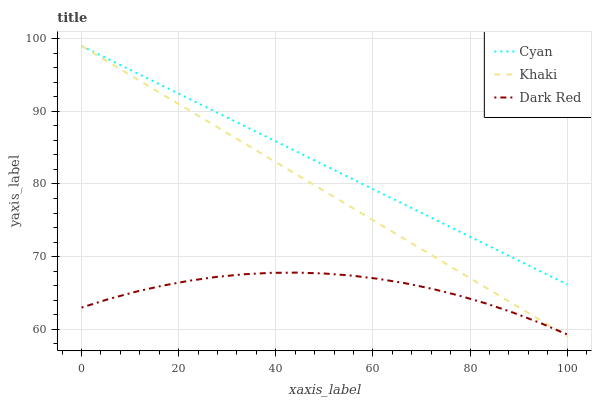Does Dark Red have the minimum area under the curve?
Answer yes or no. Yes. Does Cyan have the maximum area under the curve?
Answer yes or no. Yes. Does Khaki have the minimum area under the curve?
Answer yes or no. No. Does Khaki have the maximum area under the curve?
Answer yes or no. No. Is Khaki the smoothest?
Answer yes or no. Yes. Is Dark Red the roughest?
Answer yes or no. Yes. Is Dark Red the smoothest?
Answer yes or no. No. Is Khaki the roughest?
Answer yes or no. No. Does Khaki have the lowest value?
Answer yes or no. Yes. Does Dark Red have the lowest value?
Answer yes or no. No. Does Khaki have the highest value?
Answer yes or no. Yes. Does Dark Red have the highest value?
Answer yes or no. No. Is Dark Red less than Cyan?
Answer yes or no. Yes. Is Cyan greater than Dark Red?
Answer yes or no. Yes. Does Khaki intersect Dark Red?
Answer yes or no. Yes. Is Khaki less than Dark Red?
Answer yes or no. No. Is Khaki greater than Dark Red?
Answer yes or no. No. Does Dark Red intersect Cyan?
Answer yes or no. No. 